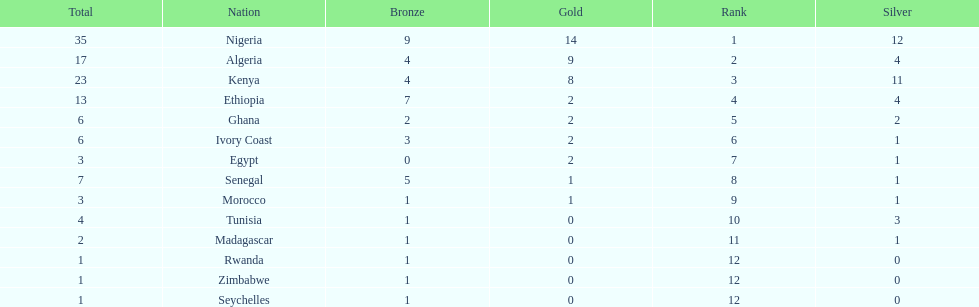How long is the list of countries that won any medals? 14. 